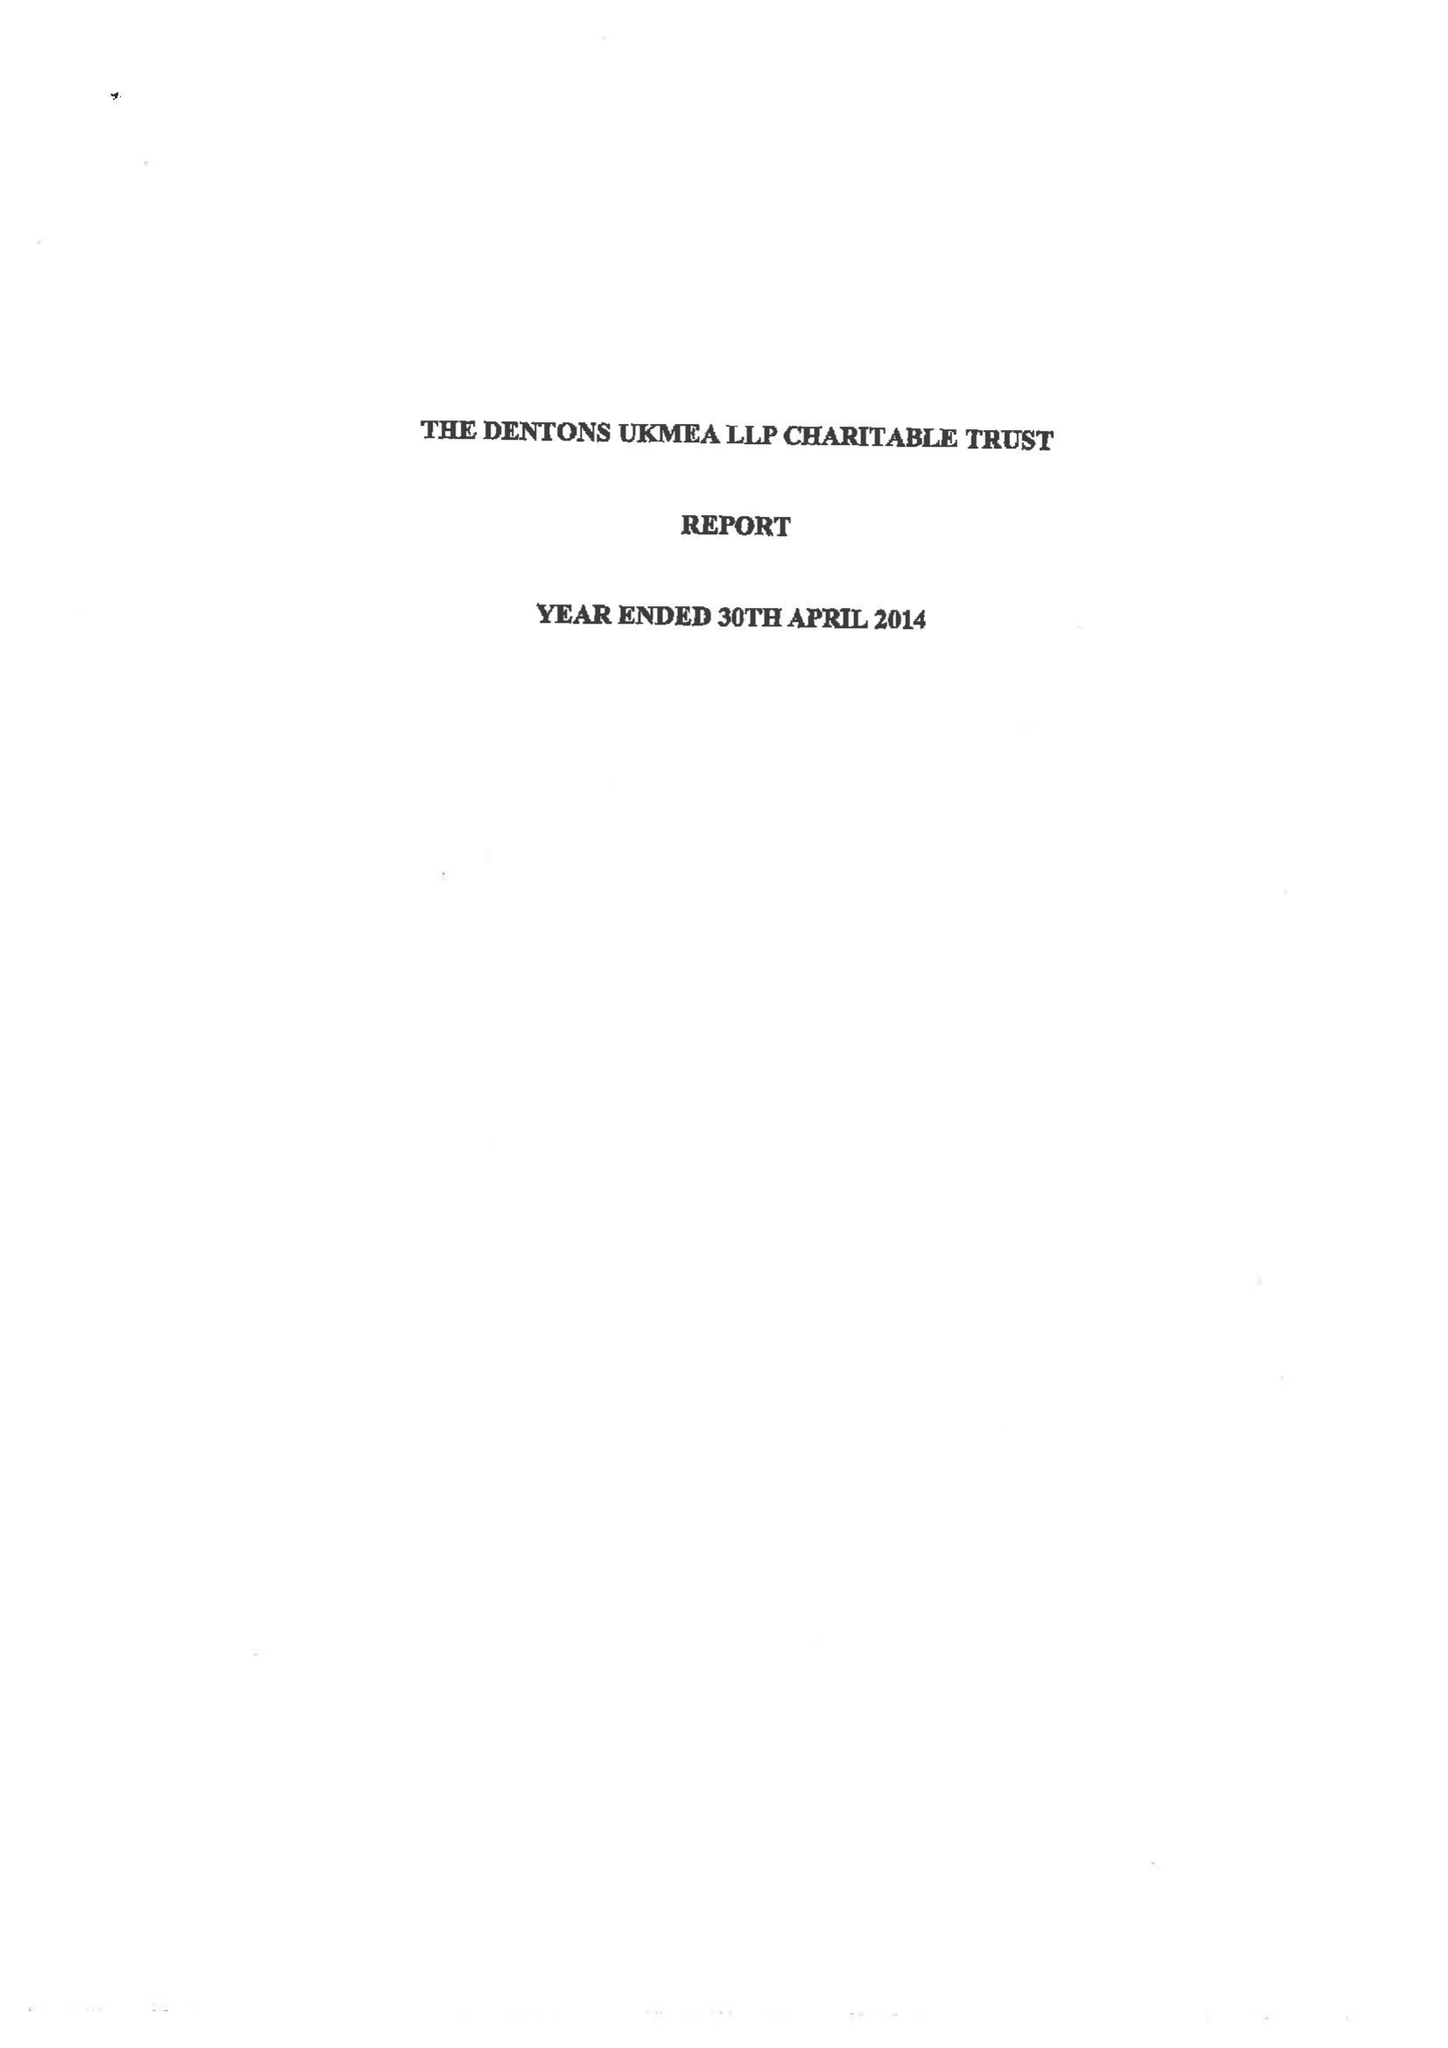What is the value for the address__postcode?
Answer the question using a single word or phrase. EC4M 7WS 